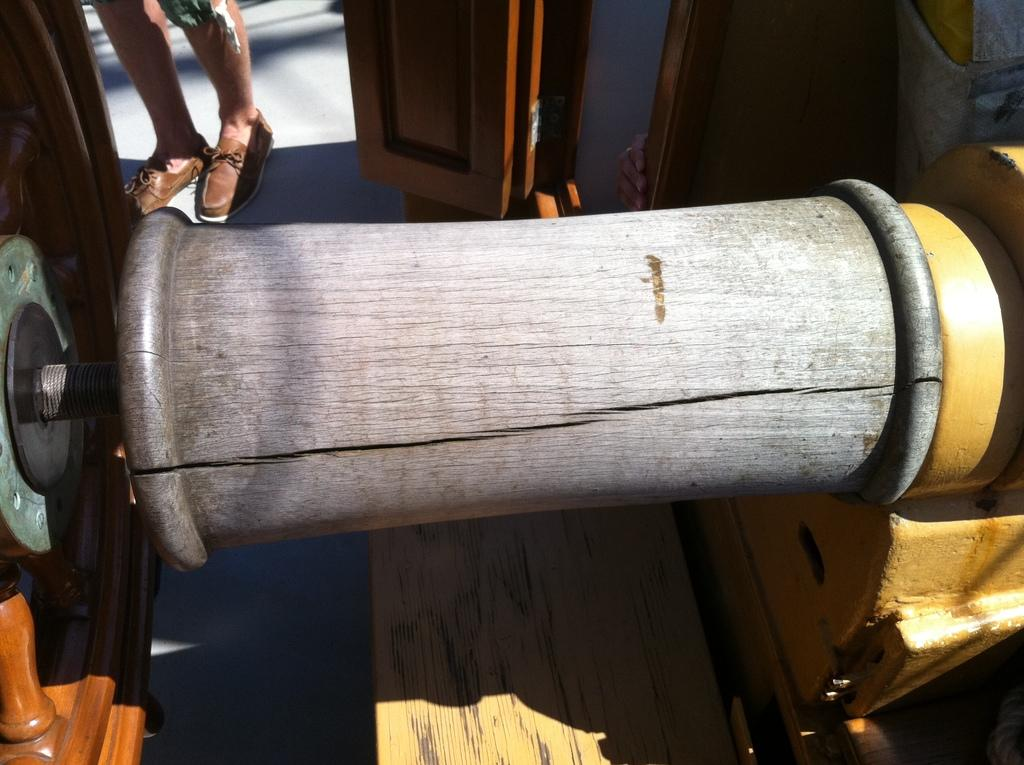What type of machine is present in the image? There is a wooden machine in the image. Can you describe the machine's appearance? The machine is made of wood. Whose legs are visible at the top of the image? The legs of a person are visible at the top of the image. What is the condition of the minister's flight in the image? There is no minister or flight present in the image. 